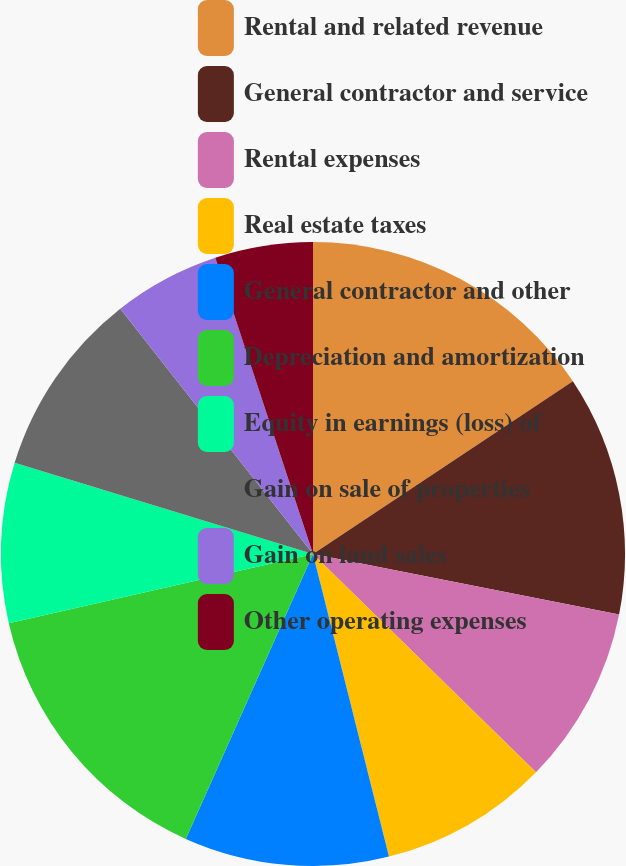Convert chart to OTSL. <chart><loc_0><loc_0><loc_500><loc_500><pie_chart><fcel>Rental and related revenue<fcel>General contractor and service<fcel>Rental expenses<fcel>Real estate taxes<fcel>General contractor and other<fcel>Depreciation and amortization<fcel>Equity in earnings (loss) of<fcel>Gain on sale of properties<fcel>Gain on land sales<fcel>Other operating expenses<nl><fcel>15.67%<fcel>12.44%<fcel>9.22%<fcel>8.76%<fcel>10.6%<fcel>14.75%<fcel>8.29%<fcel>9.68%<fcel>5.53%<fcel>5.07%<nl></chart> 